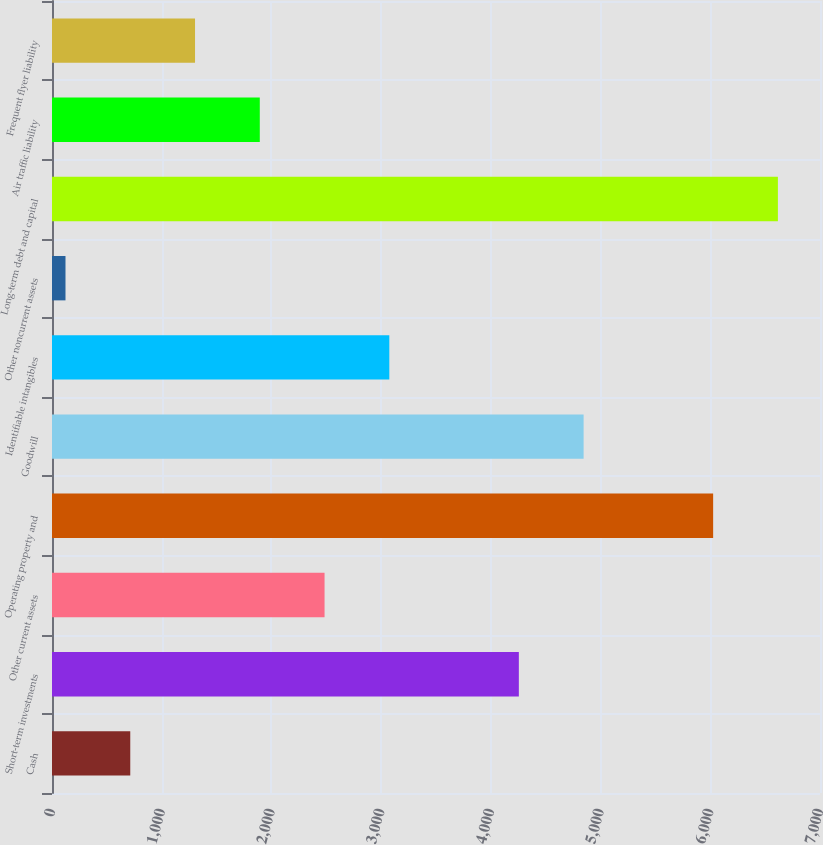Convert chart. <chart><loc_0><loc_0><loc_500><loc_500><bar_chart><fcel>Cash<fcel>Short-term investments<fcel>Other current assets<fcel>Operating property and<fcel>Goodwill<fcel>Identifiable intangibles<fcel>Other noncurrent assets<fcel>Long-term debt and capital<fcel>Air traffic liability<fcel>Frequent flyer liability<nl><fcel>713.3<fcel>4255.1<fcel>2484.2<fcel>6026<fcel>4845.4<fcel>3074.5<fcel>123<fcel>6616.3<fcel>1893.9<fcel>1303.6<nl></chart> 